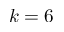<formula> <loc_0><loc_0><loc_500><loc_500>k = 6</formula> 